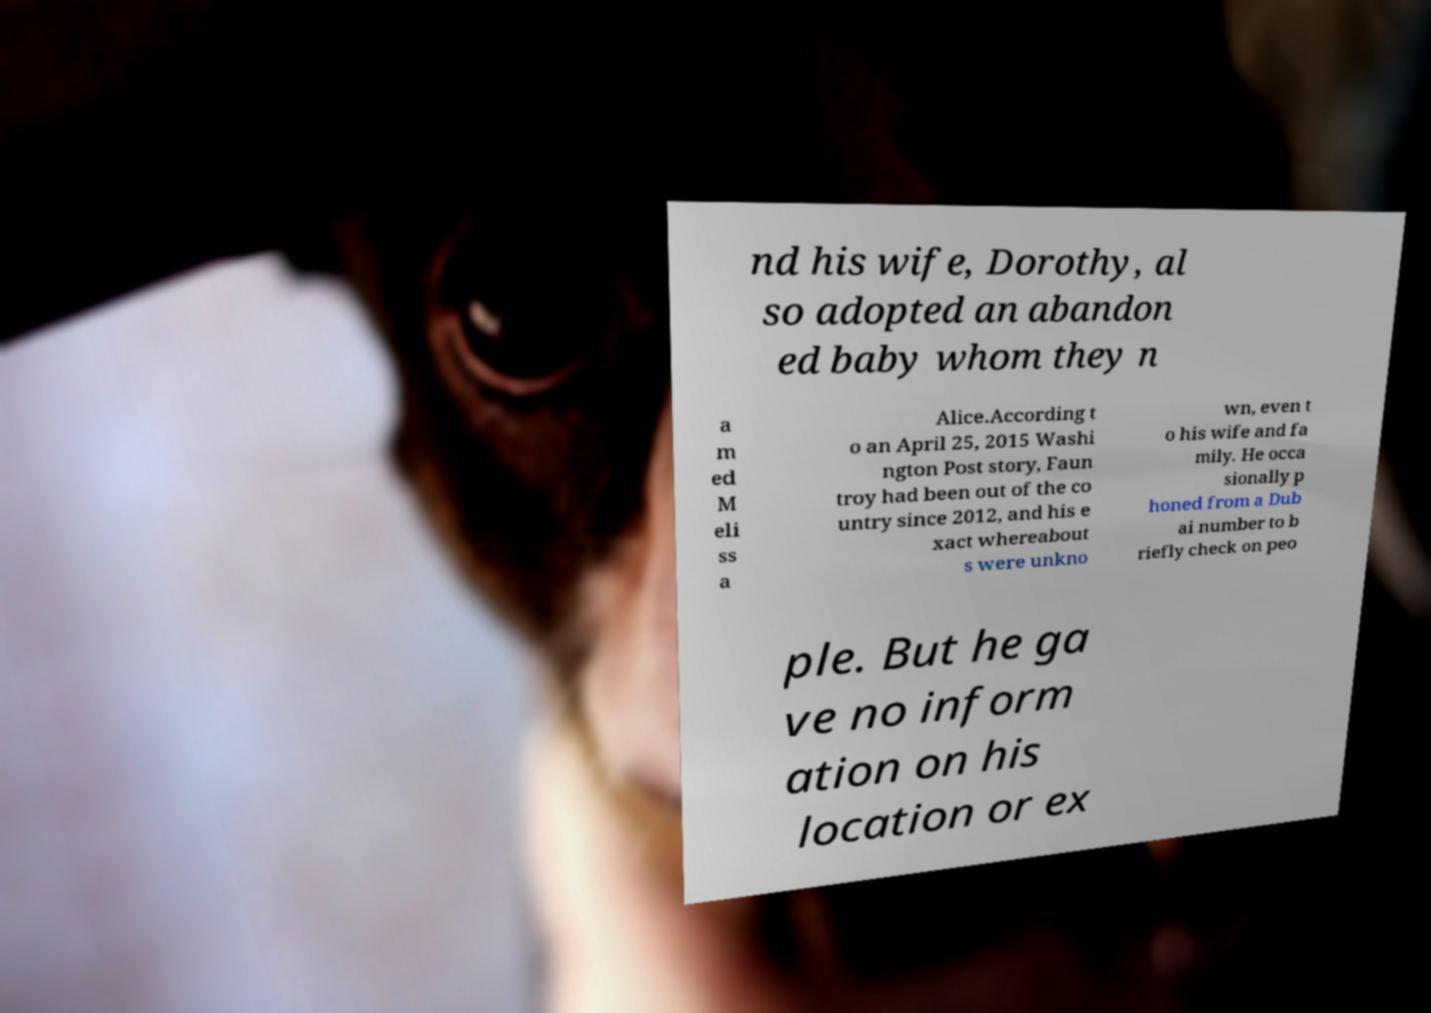Can you read and provide the text displayed in the image?This photo seems to have some interesting text. Can you extract and type it out for me? nd his wife, Dorothy, al so adopted an abandon ed baby whom they n a m ed M eli ss a Alice.According t o an April 25, 2015 Washi ngton Post story, Faun troy had been out of the co untry since 2012, and his e xact whereabout s were unkno wn, even t o his wife and fa mily. He occa sionally p honed from a Dub ai number to b riefly check on peo ple. But he ga ve no inform ation on his location or ex 